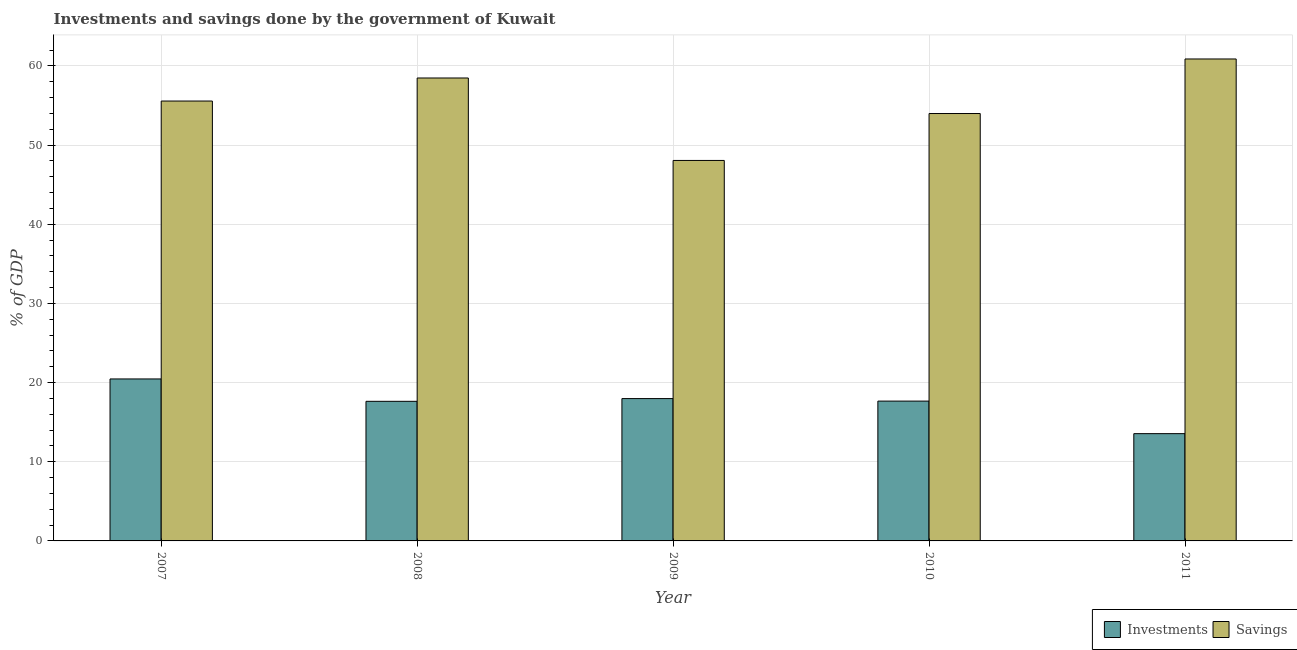How many different coloured bars are there?
Provide a short and direct response. 2. How many groups of bars are there?
Your answer should be compact. 5. Are the number of bars on each tick of the X-axis equal?
Offer a very short reply. Yes. How many bars are there on the 3rd tick from the left?
Ensure brevity in your answer.  2. What is the label of the 5th group of bars from the left?
Offer a very short reply. 2011. What is the investments of government in 2009?
Provide a short and direct response. 17.98. Across all years, what is the maximum investments of government?
Give a very brief answer. 20.46. Across all years, what is the minimum investments of government?
Your answer should be very brief. 13.55. In which year was the savings of government maximum?
Keep it short and to the point. 2011. What is the total investments of government in the graph?
Give a very brief answer. 87.27. What is the difference between the investments of government in 2008 and that in 2009?
Ensure brevity in your answer.  -0.35. What is the difference between the investments of government in 2010 and the savings of government in 2007?
Your answer should be very brief. -2.8. What is the average investments of government per year?
Provide a short and direct response. 17.45. In the year 2011, what is the difference between the investments of government and savings of government?
Provide a short and direct response. 0. What is the ratio of the investments of government in 2007 to that in 2009?
Keep it short and to the point. 1.14. Is the investments of government in 2009 less than that in 2011?
Give a very brief answer. No. What is the difference between the highest and the second highest savings of government?
Make the answer very short. 2.4. What is the difference between the highest and the lowest savings of government?
Provide a succinct answer. 12.82. In how many years, is the investments of government greater than the average investments of government taken over all years?
Give a very brief answer. 4. Is the sum of the savings of government in 2007 and 2009 greater than the maximum investments of government across all years?
Make the answer very short. Yes. What does the 1st bar from the left in 2011 represents?
Your answer should be very brief. Investments. What does the 1st bar from the right in 2011 represents?
Your response must be concise. Savings. How many years are there in the graph?
Your answer should be compact. 5. What is the difference between two consecutive major ticks on the Y-axis?
Provide a short and direct response. 10. Are the values on the major ticks of Y-axis written in scientific E-notation?
Provide a succinct answer. No. Does the graph contain any zero values?
Your answer should be very brief. No. Does the graph contain grids?
Your answer should be very brief. Yes. How are the legend labels stacked?
Give a very brief answer. Horizontal. What is the title of the graph?
Your answer should be very brief. Investments and savings done by the government of Kuwait. What is the label or title of the X-axis?
Offer a very short reply. Year. What is the label or title of the Y-axis?
Provide a succinct answer. % of GDP. What is the % of GDP in Investments in 2007?
Your answer should be very brief. 20.46. What is the % of GDP of Savings in 2007?
Offer a very short reply. 55.55. What is the % of GDP in Investments in 2008?
Your response must be concise. 17.63. What is the % of GDP of Savings in 2008?
Ensure brevity in your answer.  58.47. What is the % of GDP of Investments in 2009?
Your response must be concise. 17.98. What is the % of GDP in Savings in 2009?
Give a very brief answer. 48.05. What is the % of GDP of Investments in 2010?
Provide a succinct answer. 17.66. What is the % of GDP in Savings in 2010?
Your response must be concise. 53.98. What is the % of GDP of Investments in 2011?
Keep it short and to the point. 13.55. What is the % of GDP of Savings in 2011?
Make the answer very short. 60.87. Across all years, what is the maximum % of GDP in Investments?
Your answer should be very brief. 20.46. Across all years, what is the maximum % of GDP of Savings?
Make the answer very short. 60.87. Across all years, what is the minimum % of GDP in Investments?
Provide a short and direct response. 13.55. Across all years, what is the minimum % of GDP in Savings?
Make the answer very short. 48.05. What is the total % of GDP of Investments in the graph?
Offer a terse response. 87.27. What is the total % of GDP of Savings in the graph?
Offer a very short reply. 276.91. What is the difference between the % of GDP of Investments in 2007 and that in 2008?
Offer a very short reply. 2.83. What is the difference between the % of GDP in Savings in 2007 and that in 2008?
Give a very brief answer. -2.91. What is the difference between the % of GDP in Investments in 2007 and that in 2009?
Make the answer very short. 2.48. What is the difference between the % of GDP in Savings in 2007 and that in 2009?
Give a very brief answer. 7.5. What is the difference between the % of GDP in Investments in 2007 and that in 2010?
Offer a very short reply. 2.8. What is the difference between the % of GDP in Savings in 2007 and that in 2010?
Your response must be concise. 1.58. What is the difference between the % of GDP of Investments in 2007 and that in 2011?
Ensure brevity in your answer.  6.91. What is the difference between the % of GDP of Savings in 2007 and that in 2011?
Offer a terse response. -5.31. What is the difference between the % of GDP in Investments in 2008 and that in 2009?
Make the answer very short. -0.35. What is the difference between the % of GDP in Savings in 2008 and that in 2009?
Provide a succinct answer. 10.41. What is the difference between the % of GDP of Investments in 2008 and that in 2010?
Ensure brevity in your answer.  -0.03. What is the difference between the % of GDP in Savings in 2008 and that in 2010?
Provide a succinct answer. 4.49. What is the difference between the % of GDP of Investments in 2008 and that in 2011?
Your answer should be very brief. 4.08. What is the difference between the % of GDP of Savings in 2008 and that in 2011?
Offer a very short reply. -2.4. What is the difference between the % of GDP in Investments in 2009 and that in 2010?
Provide a short and direct response. 0.32. What is the difference between the % of GDP of Savings in 2009 and that in 2010?
Provide a succinct answer. -5.93. What is the difference between the % of GDP of Investments in 2009 and that in 2011?
Your answer should be compact. 4.43. What is the difference between the % of GDP in Savings in 2009 and that in 2011?
Offer a terse response. -12.82. What is the difference between the % of GDP of Investments in 2010 and that in 2011?
Provide a succinct answer. 4.11. What is the difference between the % of GDP in Savings in 2010 and that in 2011?
Your answer should be very brief. -6.89. What is the difference between the % of GDP of Investments in 2007 and the % of GDP of Savings in 2008?
Ensure brevity in your answer.  -38.01. What is the difference between the % of GDP of Investments in 2007 and the % of GDP of Savings in 2009?
Provide a succinct answer. -27.59. What is the difference between the % of GDP of Investments in 2007 and the % of GDP of Savings in 2010?
Make the answer very short. -33.52. What is the difference between the % of GDP of Investments in 2007 and the % of GDP of Savings in 2011?
Make the answer very short. -40.41. What is the difference between the % of GDP of Investments in 2008 and the % of GDP of Savings in 2009?
Give a very brief answer. -30.42. What is the difference between the % of GDP of Investments in 2008 and the % of GDP of Savings in 2010?
Offer a very short reply. -36.35. What is the difference between the % of GDP in Investments in 2008 and the % of GDP in Savings in 2011?
Provide a succinct answer. -43.24. What is the difference between the % of GDP of Investments in 2009 and the % of GDP of Savings in 2010?
Ensure brevity in your answer.  -36. What is the difference between the % of GDP in Investments in 2009 and the % of GDP in Savings in 2011?
Offer a terse response. -42.89. What is the difference between the % of GDP in Investments in 2010 and the % of GDP in Savings in 2011?
Your answer should be very brief. -43.21. What is the average % of GDP of Investments per year?
Provide a succinct answer. 17.45. What is the average % of GDP of Savings per year?
Ensure brevity in your answer.  55.38. In the year 2007, what is the difference between the % of GDP in Investments and % of GDP in Savings?
Ensure brevity in your answer.  -35.1. In the year 2008, what is the difference between the % of GDP in Investments and % of GDP in Savings?
Offer a very short reply. -40.84. In the year 2009, what is the difference between the % of GDP in Investments and % of GDP in Savings?
Keep it short and to the point. -30.07. In the year 2010, what is the difference between the % of GDP of Investments and % of GDP of Savings?
Make the answer very short. -36.32. In the year 2011, what is the difference between the % of GDP of Investments and % of GDP of Savings?
Your response must be concise. -47.32. What is the ratio of the % of GDP of Investments in 2007 to that in 2008?
Your answer should be very brief. 1.16. What is the ratio of the % of GDP in Savings in 2007 to that in 2008?
Keep it short and to the point. 0.95. What is the ratio of the % of GDP of Investments in 2007 to that in 2009?
Your answer should be very brief. 1.14. What is the ratio of the % of GDP of Savings in 2007 to that in 2009?
Your response must be concise. 1.16. What is the ratio of the % of GDP in Investments in 2007 to that in 2010?
Offer a very short reply. 1.16. What is the ratio of the % of GDP in Savings in 2007 to that in 2010?
Ensure brevity in your answer.  1.03. What is the ratio of the % of GDP of Investments in 2007 to that in 2011?
Provide a succinct answer. 1.51. What is the ratio of the % of GDP of Savings in 2007 to that in 2011?
Give a very brief answer. 0.91. What is the ratio of the % of GDP of Investments in 2008 to that in 2009?
Offer a very short reply. 0.98. What is the ratio of the % of GDP of Savings in 2008 to that in 2009?
Make the answer very short. 1.22. What is the ratio of the % of GDP of Savings in 2008 to that in 2010?
Offer a very short reply. 1.08. What is the ratio of the % of GDP of Investments in 2008 to that in 2011?
Provide a succinct answer. 1.3. What is the ratio of the % of GDP in Savings in 2008 to that in 2011?
Keep it short and to the point. 0.96. What is the ratio of the % of GDP of Savings in 2009 to that in 2010?
Give a very brief answer. 0.89. What is the ratio of the % of GDP of Investments in 2009 to that in 2011?
Your answer should be compact. 1.33. What is the ratio of the % of GDP in Savings in 2009 to that in 2011?
Give a very brief answer. 0.79. What is the ratio of the % of GDP of Investments in 2010 to that in 2011?
Keep it short and to the point. 1.3. What is the ratio of the % of GDP in Savings in 2010 to that in 2011?
Your answer should be very brief. 0.89. What is the difference between the highest and the second highest % of GDP in Investments?
Provide a short and direct response. 2.48. What is the difference between the highest and the second highest % of GDP of Savings?
Your answer should be very brief. 2.4. What is the difference between the highest and the lowest % of GDP in Investments?
Your response must be concise. 6.91. What is the difference between the highest and the lowest % of GDP in Savings?
Provide a succinct answer. 12.82. 